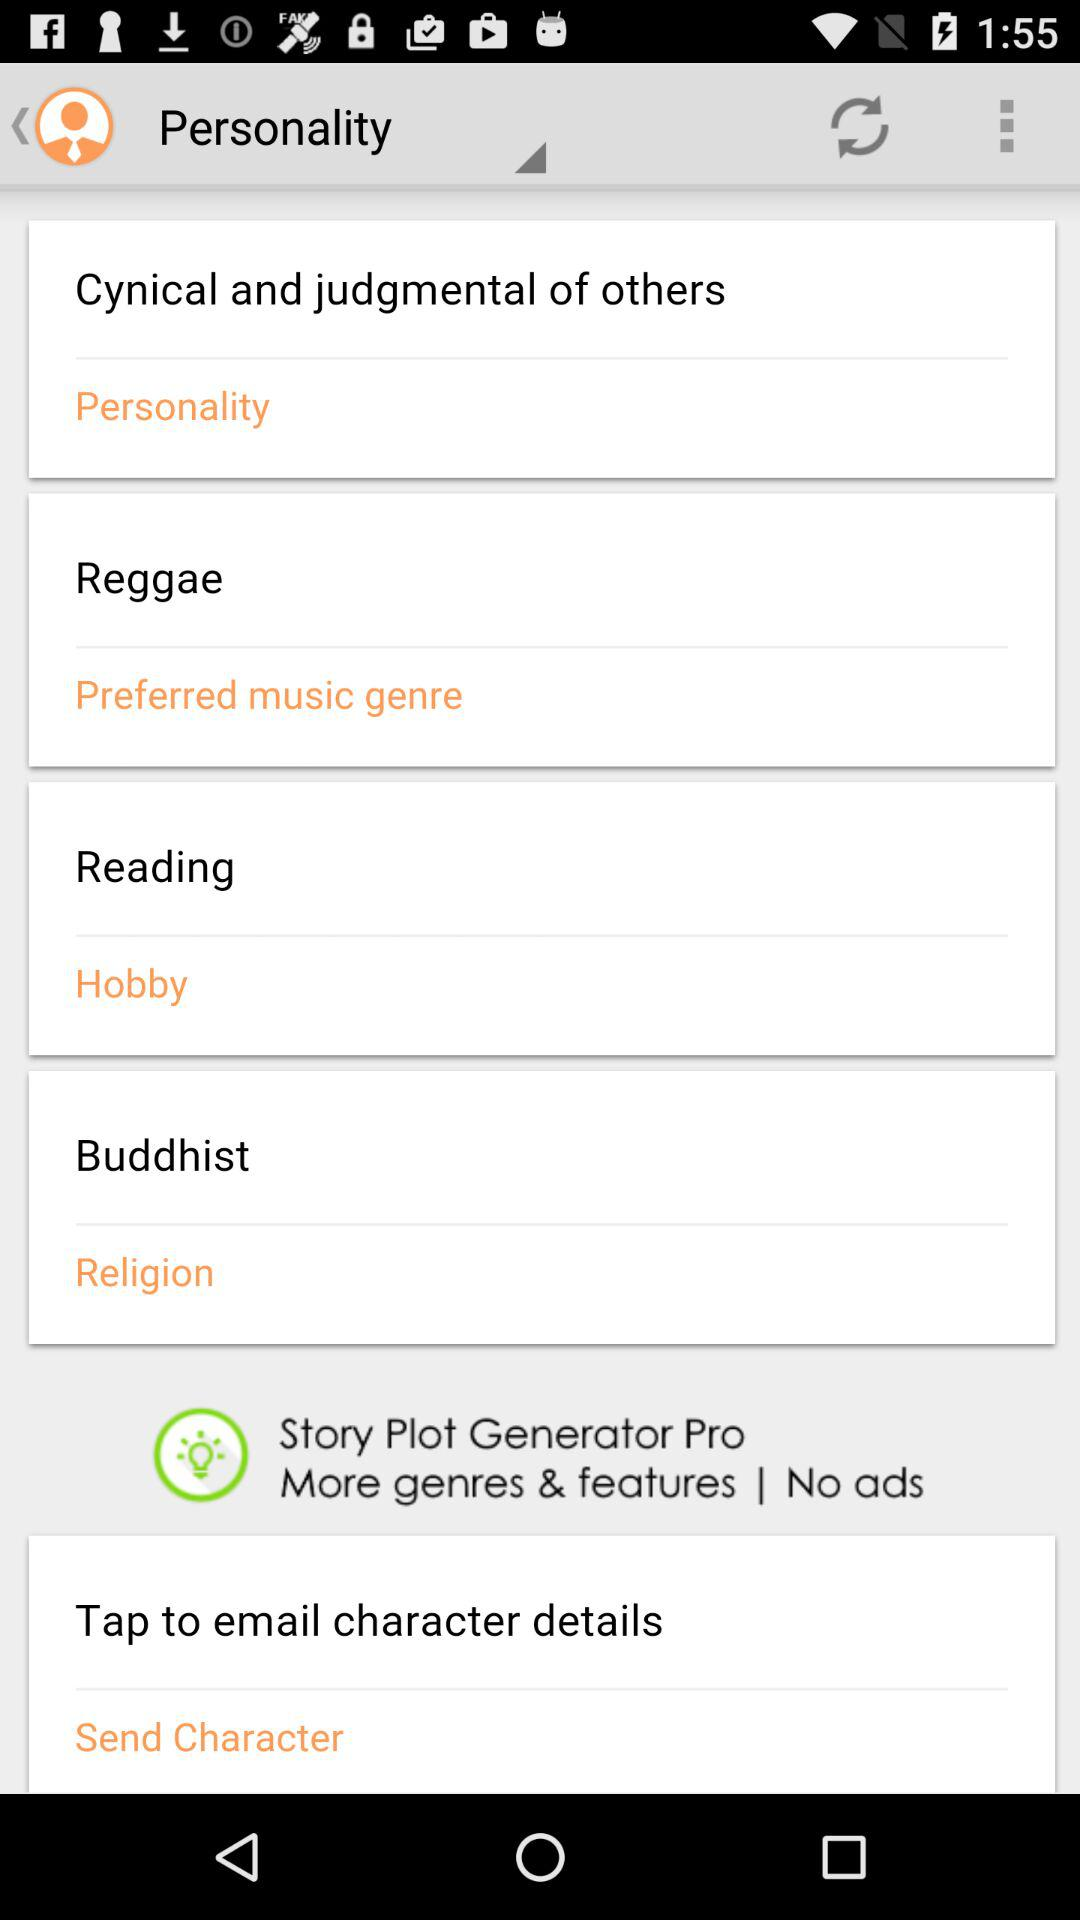What type of personality is mentioned? The mentioned personality type is "Cynical and judgmental of others". 